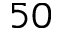Convert formula to latex. <formula><loc_0><loc_0><loc_500><loc_500>5 0</formula> 